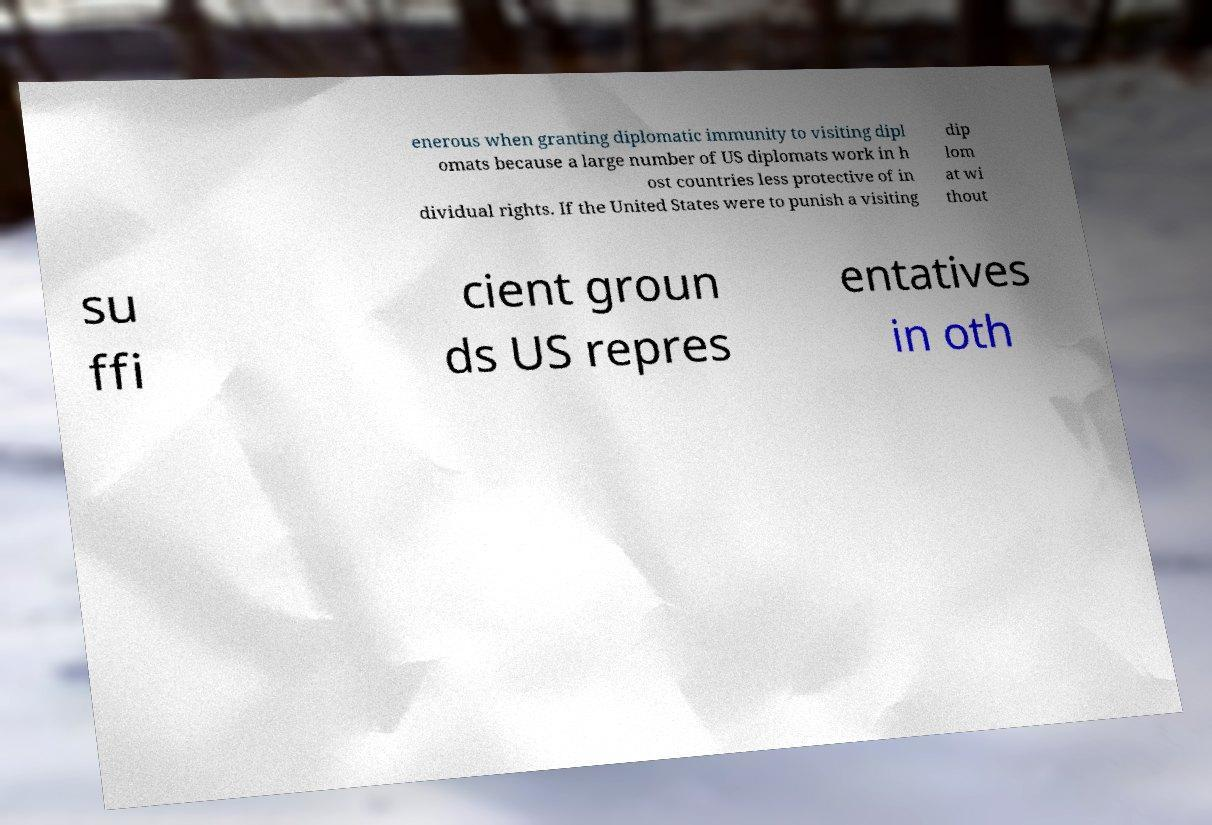Can you read and provide the text displayed in the image?This photo seems to have some interesting text. Can you extract and type it out for me? enerous when granting diplomatic immunity to visiting dipl omats because a large number of US diplomats work in h ost countries less protective of in dividual rights. If the United States were to punish a visiting dip lom at wi thout su ffi cient groun ds US repres entatives in oth 